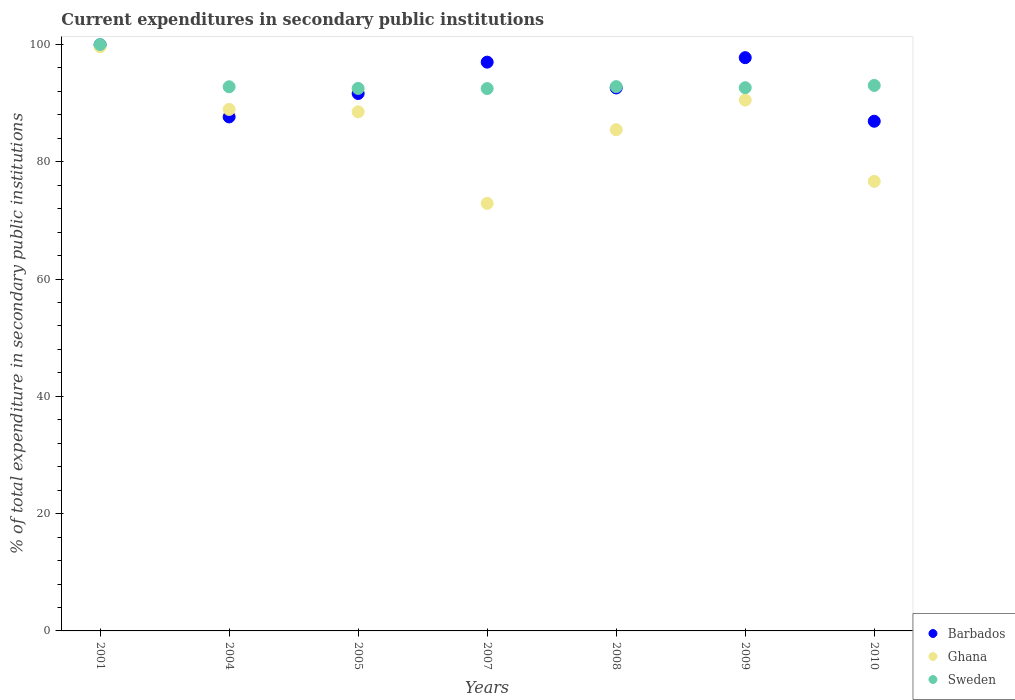How many different coloured dotlines are there?
Offer a very short reply. 3. What is the current expenditures in secondary public institutions in Sweden in 2010?
Give a very brief answer. 93.02. Across all years, what is the maximum current expenditures in secondary public institutions in Ghana?
Offer a very short reply. 99.62. Across all years, what is the minimum current expenditures in secondary public institutions in Ghana?
Provide a succinct answer. 72.91. In which year was the current expenditures in secondary public institutions in Sweden maximum?
Ensure brevity in your answer.  2001. In which year was the current expenditures in secondary public institutions in Barbados minimum?
Ensure brevity in your answer.  2010. What is the total current expenditures in secondary public institutions in Sweden in the graph?
Give a very brief answer. 656.27. What is the difference between the current expenditures in secondary public institutions in Ghana in 2001 and that in 2010?
Your answer should be compact. 22.95. What is the difference between the current expenditures in secondary public institutions in Sweden in 2005 and the current expenditures in secondary public institutions in Barbados in 2008?
Provide a short and direct response. -0.08. What is the average current expenditures in secondary public institutions in Sweden per year?
Your answer should be compact. 93.75. In the year 2001, what is the difference between the current expenditures in secondary public institutions in Barbados and current expenditures in secondary public institutions in Sweden?
Offer a very short reply. -0.06. What is the ratio of the current expenditures in secondary public institutions in Sweden in 2001 to that in 2004?
Your answer should be very brief. 1.08. Is the current expenditures in secondary public institutions in Barbados in 2005 less than that in 2010?
Provide a succinct answer. No. What is the difference between the highest and the second highest current expenditures in secondary public institutions in Sweden?
Your response must be concise. 6.98. What is the difference between the highest and the lowest current expenditures in secondary public institutions in Ghana?
Offer a terse response. 26.71. Is the sum of the current expenditures in secondary public institutions in Ghana in 2001 and 2004 greater than the maximum current expenditures in secondary public institutions in Sweden across all years?
Offer a very short reply. Yes. Is it the case that in every year, the sum of the current expenditures in secondary public institutions in Ghana and current expenditures in secondary public institutions in Sweden  is greater than the current expenditures in secondary public institutions in Barbados?
Offer a terse response. Yes. Is the current expenditures in secondary public institutions in Barbados strictly greater than the current expenditures in secondary public institutions in Sweden over the years?
Give a very brief answer. No. How many dotlines are there?
Your response must be concise. 3. How many years are there in the graph?
Offer a very short reply. 7. Does the graph contain any zero values?
Your response must be concise. No. Where does the legend appear in the graph?
Provide a short and direct response. Bottom right. How are the legend labels stacked?
Ensure brevity in your answer.  Vertical. What is the title of the graph?
Your answer should be compact. Current expenditures in secondary public institutions. Does "Libya" appear as one of the legend labels in the graph?
Your answer should be compact. No. What is the label or title of the X-axis?
Make the answer very short. Years. What is the label or title of the Y-axis?
Your answer should be compact. % of total expenditure in secondary public institutions. What is the % of total expenditure in secondary public institutions in Barbados in 2001?
Your response must be concise. 99.94. What is the % of total expenditure in secondary public institutions of Ghana in 2001?
Provide a succinct answer. 99.62. What is the % of total expenditure in secondary public institutions in Sweden in 2001?
Make the answer very short. 100. What is the % of total expenditure in secondary public institutions of Barbados in 2004?
Your answer should be very brief. 87.65. What is the % of total expenditure in secondary public institutions of Ghana in 2004?
Offer a terse response. 88.93. What is the % of total expenditure in secondary public institutions in Sweden in 2004?
Your answer should be compact. 92.79. What is the % of total expenditure in secondary public institutions of Barbados in 2005?
Ensure brevity in your answer.  91.65. What is the % of total expenditure in secondary public institutions of Ghana in 2005?
Offer a very short reply. 88.52. What is the % of total expenditure in secondary public institutions in Sweden in 2005?
Your answer should be very brief. 92.51. What is the % of total expenditure in secondary public institutions in Barbados in 2007?
Give a very brief answer. 96.99. What is the % of total expenditure in secondary public institutions of Ghana in 2007?
Provide a short and direct response. 72.91. What is the % of total expenditure in secondary public institutions in Sweden in 2007?
Keep it short and to the point. 92.49. What is the % of total expenditure in secondary public institutions in Barbados in 2008?
Provide a succinct answer. 92.59. What is the % of total expenditure in secondary public institutions of Ghana in 2008?
Provide a succinct answer. 85.48. What is the % of total expenditure in secondary public institutions of Sweden in 2008?
Give a very brief answer. 92.82. What is the % of total expenditure in secondary public institutions in Barbados in 2009?
Offer a terse response. 97.76. What is the % of total expenditure in secondary public institutions in Ghana in 2009?
Provide a succinct answer. 90.52. What is the % of total expenditure in secondary public institutions in Sweden in 2009?
Ensure brevity in your answer.  92.63. What is the % of total expenditure in secondary public institutions of Barbados in 2010?
Keep it short and to the point. 86.92. What is the % of total expenditure in secondary public institutions in Ghana in 2010?
Make the answer very short. 76.67. What is the % of total expenditure in secondary public institutions in Sweden in 2010?
Your answer should be compact. 93.02. Across all years, what is the maximum % of total expenditure in secondary public institutions of Barbados?
Ensure brevity in your answer.  99.94. Across all years, what is the maximum % of total expenditure in secondary public institutions in Ghana?
Keep it short and to the point. 99.62. Across all years, what is the minimum % of total expenditure in secondary public institutions in Barbados?
Offer a very short reply. 86.92. Across all years, what is the minimum % of total expenditure in secondary public institutions of Ghana?
Offer a terse response. 72.91. Across all years, what is the minimum % of total expenditure in secondary public institutions of Sweden?
Keep it short and to the point. 92.49. What is the total % of total expenditure in secondary public institutions of Barbados in the graph?
Your response must be concise. 653.51. What is the total % of total expenditure in secondary public institutions of Ghana in the graph?
Your answer should be compact. 602.64. What is the total % of total expenditure in secondary public institutions of Sweden in the graph?
Provide a short and direct response. 656.27. What is the difference between the % of total expenditure in secondary public institutions of Barbados in 2001 and that in 2004?
Offer a very short reply. 12.29. What is the difference between the % of total expenditure in secondary public institutions in Ghana in 2001 and that in 2004?
Your answer should be very brief. 10.69. What is the difference between the % of total expenditure in secondary public institutions in Sweden in 2001 and that in 2004?
Your response must be concise. 7.21. What is the difference between the % of total expenditure in secondary public institutions in Barbados in 2001 and that in 2005?
Make the answer very short. 8.29. What is the difference between the % of total expenditure in secondary public institutions of Ghana in 2001 and that in 2005?
Your answer should be compact. 11.09. What is the difference between the % of total expenditure in secondary public institutions of Sweden in 2001 and that in 2005?
Provide a succinct answer. 7.49. What is the difference between the % of total expenditure in secondary public institutions in Barbados in 2001 and that in 2007?
Give a very brief answer. 2.95. What is the difference between the % of total expenditure in secondary public institutions in Ghana in 2001 and that in 2007?
Ensure brevity in your answer.  26.71. What is the difference between the % of total expenditure in secondary public institutions in Sweden in 2001 and that in 2007?
Provide a short and direct response. 7.51. What is the difference between the % of total expenditure in secondary public institutions in Barbados in 2001 and that in 2008?
Ensure brevity in your answer.  7.35. What is the difference between the % of total expenditure in secondary public institutions of Ghana in 2001 and that in 2008?
Make the answer very short. 14.14. What is the difference between the % of total expenditure in secondary public institutions in Sweden in 2001 and that in 2008?
Keep it short and to the point. 7.18. What is the difference between the % of total expenditure in secondary public institutions of Barbados in 2001 and that in 2009?
Make the answer very short. 2.18. What is the difference between the % of total expenditure in secondary public institutions in Ghana in 2001 and that in 2009?
Ensure brevity in your answer.  9.1. What is the difference between the % of total expenditure in secondary public institutions in Sweden in 2001 and that in 2009?
Give a very brief answer. 7.37. What is the difference between the % of total expenditure in secondary public institutions in Barbados in 2001 and that in 2010?
Provide a short and direct response. 13.03. What is the difference between the % of total expenditure in secondary public institutions in Ghana in 2001 and that in 2010?
Offer a very short reply. 22.95. What is the difference between the % of total expenditure in secondary public institutions of Sweden in 2001 and that in 2010?
Offer a very short reply. 6.98. What is the difference between the % of total expenditure in secondary public institutions of Barbados in 2004 and that in 2005?
Make the answer very short. -3.99. What is the difference between the % of total expenditure in secondary public institutions of Ghana in 2004 and that in 2005?
Make the answer very short. 0.4. What is the difference between the % of total expenditure in secondary public institutions in Sweden in 2004 and that in 2005?
Your answer should be compact. 0.28. What is the difference between the % of total expenditure in secondary public institutions of Barbados in 2004 and that in 2007?
Your response must be concise. -9.34. What is the difference between the % of total expenditure in secondary public institutions of Ghana in 2004 and that in 2007?
Provide a succinct answer. 16.02. What is the difference between the % of total expenditure in secondary public institutions of Sweden in 2004 and that in 2007?
Offer a very short reply. 0.3. What is the difference between the % of total expenditure in secondary public institutions of Barbados in 2004 and that in 2008?
Give a very brief answer. -4.94. What is the difference between the % of total expenditure in secondary public institutions of Ghana in 2004 and that in 2008?
Your answer should be compact. 3.45. What is the difference between the % of total expenditure in secondary public institutions of Sweden in 2004 and that in 2008?
Provide a succinct answer. -0.03. What is the difference between the % of total expenditure in secondary public institutions of Barbados in 2004 and that in 2009?
Your response must be concise. -10.1. What is the difference between the % of total expenditure in secondary public institutions of Ghana in 2004 and that in 2009?
Your answer should be very brief. -1.59. What is the difference between the % of total expenditure in secondary public institutions of Sweden in 2004 and that in 2009?
Make the answer very short. 0.16. What is the difference between the % of total expenditure in secondary public institutions in Barbados in 2004 and that in 2010?
Give a very brief answer. 0.74. What is the difference between the % of total expenditure in secondary public institutions in Ghana in 2004 and that in 2010?
Provide a succinct answer. 12.26. What is the difference between the % of total expenditure in secondary public institutions of Sweden in 2004 and that in 2010?
Offer a terse response. -0.23. What is the difference between the % of total expenditure in secondary public institutions in Barbados in 2005 and that in 2007?
Provide a short and direct response. -5.35. What is the difference between the % of total expenditure in secondary public institutions of Ghana in 2005 and that in 2007?
Offer a terse response. 15.61. What is the difference between the % of total expenditure in secondary public institutions in Sweden in 2005 and that in 2007?
Your answer should be very brief. 0.02. What is the difference between the % of total expenditure in secondary public institutions in Barbados in 2005 and that in 2008?
Provide a succinct answer. -0.95. What is the difference between the % of total expenditure in secondary public institutions in Ghana in 2005 and that in 2008?
Provide a short and direct response. 3.05. What is the difference between the % of total expenditure in secondary public institutions in Sweden in 2005 and that in 2008?
Give a very brief answer. -0.31. What is the difference between the % of total expenditure in secondary public institutions in Barbados in 2005 and that in 2009?
Give a very brief answer. -6.11. What is the difference between the % of total expenditure in secondary public institutions of Ghana in 2005 and that in 2009?
Offer a very short reply. -2. What is the difference between the % of total expenditure in secondary public institutions of Sweden in 2005 and that in 2009?
Your answer should be compact. -0.12. What is the difference between the % of total expenditure in secondary public institutions of Barbados in 2005 and that in 2010?
Give a very brief answer. 4.73. What is the difference between the % of total expenditure in secondary public institutions in Ghana in 2005 and that in 2010?
Give a very brief answer. 11.86. What is the difference between the % of total expenditure in secondary public institutions of Sweden in 2005 and that in 2010?
Ensure brevity in your answer.  -0.51. What is the difference between the % of total expenditure in secondary public institutions of Barbados in 2007 and that in 2008?
Ensure brevity in your answer.  4.4. What is the difference between the % of total expenditure in secondary public institutions of Ghana in 2007 and that in 2008?
Offer a terse response. -12.57. What is the difference between the % of total expenditure in secondary public institutions of Sweden in 2007 and that in 2008?
Offer a very short reply. -0.33. What is the difference between the % of total expenditure in secondary public institutions in Barbados in 2007 and that in 2009?
Give a very brief answer. -0.76. What is the difference between the % of total expenditure in secondary public institutions of Ghana in 2007 and that in 2009?
Provide a succinct answer. -17.61. What is the difference between the % of total expenditure in secondary public institutions in Sweden in 2007 and that in 2009?
Keep it short and to the point. -0.15. What is the difference between the % of total expenditure in secondary public institutions in Barbados in 2007 and that in 2010?
Ensure brevity in your answer.  10.08. What is the difference between the % of total expenditure in secondary public institutions of Ghana in 2007 and that in 2010?
Your answer should be compact. -3.76. What is the difference between the % of total expenditure in secondary public institutions in Sweden in 2007 and that in 2010?
Give a very brief answer. -0.54. What is the difference between the % of total expenditure in secondary public institutions of Barbados in 2008 and that in 2009?
Provide a short and direct response. -5.16. What is the difference between the % of total expenditure in secondary public institutions in Ghana in 2008 and that in 2009?
Give a very brief answer. -5.04. What is the difference between the % of total expenditure in secondary public institutions of Sweden in 2008 and that in 2009?
Give a very brief answer. 0.19. What is the difference between the % of total expenditure in secondary public institutions in Barbados in 2008 and that in 2010?
Your answer should be compact. 5.68. What is the difference between the % of total expenditure in secondary public institutions of Ghana in 2008 and that in 2010?
Give a very brief answer. 8.81. What is the difference between the % of total expenditure in secondary public institutions in Sweden in 2008 and that in 2010?
Offer a terse response. -0.2. What is the difference between the % of total expenditure in secondary public institutions of Barbados in 2009 and that in 2010?
Your answer should be very brief. 10.84. What is the difference between the % of total expenditure in secondary public institutions of Ghana in 2009 and that in 2010?
Provide a succinct answer. 13.85. What is the difference between the % of total expenditure in secondary public institutions of Sweden in 2009 and that in 2010?
Your answer should be very brief. -0.39. What is the difference between the % of total expenditure in secondary public institutions in Barbados in 2001 and the % of total expenditure in secondary public institutions in Ghana in 2004?
Your response must be concise. 11.01. What is the difference between the % of total expenditure in secondary public institutions of Barbados in 2001 and the % of total expenditure in secondary public institutions of Sweden in 2004?
Give a very brief answer. 7.15. What is the difference between the % of total expenditure in secondary public institutions in Ghana in 2001 and the % of total expenditure in secondary public institutions in Sweden in 2004?
Give a very brief answer. 6.82. What is the difference between the % of total expenditure in secondary public institutions of Barbados in 2001 and the % of total expenditure in secondary public institutions of Ghana in 2005?
Give a very brief answer. 11.42. What is the difference between the % of total expenditure in secondary public institutions in Barbados in 2001 and the % of total expenditure in secondary public institutions in Sweden in 2005?
Provide a short and direct response. 7.43. What is the difference between the % of total expenditure in secondary public institutions in Ghana in 2001 and the % of total expenditure in secondary public institutions in Sweden in 2005?
Your answer should be very brief. 7.11. What is the difference between the % of total expenditure in secondary public institutions in Barbados in 2001 and the % of total expenditure in secondary public institutions in Ghana in 2007?
Offer a very short reply. 27.03. What is the difference between the % of total expenditure in secondary public institutions in Barbados in 2001 and the % of total expenditure in secondary public institutions in Sweden in 2007?
Your answer should be compact. 7.45. What is the difference between the % of total expenditure in secondary public institutions in Ghana in 2001 and the % of total expenditure in secondary public institutions in Sweden in 2007?
Your answer should be compact. 7.13. What is the difference between the % of total expenditure in secondary public institutions of Barbados in 2001 and the % of total expenditure in secondary public institutions of Ghana in 2008?
Your response must be concise. 14.46. What is the difference between the % of total expenditure in secondary public institutions of Barbados in 2001 and the % of total expenditure in secondary public institutions of Sweden in 2008?
Offer a very short reply. 7.12. What is the difference between the % of total expenditure in secondary public institutions in Ghana in 2001 and the % of total expenditure in secondary public institutions in Sweden in 2008?
Ensure brevity in your answer.  6.8. What is the difference between the % of total expenditure in secondary public institutions of Barbados in 2001 and the % of total expenditure in secondary public institutions of Ghana in 2009?
Provide a short and direct response. 9.42. What is the difference between the % of total expenditure in secondary public institutions in Barbados in 2001 and the % of total expenditure in secondary public institutions in Sweden in 2009?
Your answer should be very brief. 7.31. What is the difference between the % of total expenditure in secondary public institutions in Ghana in 2001 and the % of total expenditure in secondary public institutions in Sweden in 2009?
Your response must be concise. 6.98. What is the difference between the % of total expenditure in secondary public institutions of Barbados in 2001 and the % of total expenditure in secondary public institutions of Ghana in 2010?
Make the answer very short. 23.27. What is the difference between the % of total expenditure in secondary public institutions in Barbados in 2001 and the % of total expenditure in secondary public institutions in Sweden in 2010?
Offer a very short reply. 6.92. What is the difference between the % of total expenditure in secondary public institutions of Ghana in 2001 and the % of total expenditure in secondary public institutions of Sweden in 2010?
Offer a very short reply. 6.59. What is the difference between the % of total expenditure in secondary public institutions in Barbados in 2004 and the % of total expenditure in secondary public institutions in Ghana in 2005?
Provide a short and direct response. -0.87. What is the difference between the % of total expenditure in secondary public institutions of Barbados in 2004 and the % of total expenditure in secondary public institutions of Sweden in 2005?
Provide a succinct answer. -4.86. What is the difference between the % of total expenditure in secondary public institutions in Ghana in 2004 and the % of total expenditure in secondary public institutions in Sweden in 2005?
Your answer should be very brief. -3.58. What is the difference between the % of total expenditure in secondary public institutions of Barbados in 2004 and the % of total expenditure in secondary public institutions of Ghana in 2007?
Keep it short and to the point. 14.75. What is the difference between the % of total expenditure in secondary public institutions in Barbados in 2004 and the % of total expenditure in secondary public institutions in Sweden in 2007?
Your answer should be very brief. -4.83. What is the difference between the % of total expenditure in secondary public institutions in Ghana in 2004 and the % of total expenditure in secondary public institutions in Sweden in 2007?
Keep it short and to the point. -3.56. What is the difference between the % of total expenditure in secondary public institutions of Barbados in 2004 and the % of total expenditure in secondary public institutions of Ghana in 2008?
Offer a terse response. 2.18. What is the difference between the % of total expenditure in secondary public institutions of Barbados in 2004 and the % of total expenditure in secondary public institutions of Sweden in 2008?
Keep it short and to the point. -5.16. What is the difference between the % of total expenditure in secondary public institutions of Ghana in 2004 and the % of total expenditure in secondary public institutions of Sweden in 2008?
Provide a succinct answer. -3.89. What is the difference between the % of total expenditure in secondary public institutions in Barbados in 2004 and the % of total expenditure in secondary public institutions in Ghana in 2009?
Provide a short and direct response. -2.86. What is the difference between the % of total expenditure in secondary public institutions in Barbados in 2004 and the % of total expenditure in secondary public institutions in Sweden in 2009?
Give a very brief answer. -4.98. What is the difference between the % of total expenditure in secondary public institutions of Ghana in 2004 and the % of total expenditure in secondary public institutions of Sweden in 2009?
Give a very brief answer. -3.71. What is the difference between the % of total expenditure in secondary public institutions in Barbados in 2004 and the % of total expenditure in secondary public institutions in Ghana in 2010?
Offer a terse response. 10.99. What is the difference between the % of total expenditure in secondary public institutions in Barbados in 2004 and the % of total expenditure in secondary public institutions in Sweden in 2010?
Your answer should be very brief. -5.37. What is the difference between the % of total expenditure in secondary public institutions in Ghana in 2004 and the % of total expenditure in secondary public institutions in Sweden in 2010?
Your answer should be compact. -4.1. What is the difference between the % of total expenditure in secondary public institutions of Barbados in 2005 and the % of total expenditure in secondary public institutions of Ghana in 2007?
Your response must be concise. 18.74. What is the difference between the % of total expenditure in secondary public institutions of Barbados in 2005 and the % of total expenditure in secondary public institutions of Sweden in 2007?
Keep it short and to the point. -0.84. What is the difference between the % of total expenditure in secondary public institutions of Ghana in 2005 and the % of total expenditure in secondary public institutions of Sweden in 2007?
Keep it short and to the point. -3.97. What is the difference between the % of total expenditure in secondary public institutions in Barbados in 2005 and the % of total expenditure in secondary public institutions in Ghana in 2008?
Make the answer very short. 6.17. What is the difference between the % of total expenditure in secondary public institutions of Barbados in 2005 and the % of total expenditure in secondary public institutions of Sweden in 2008?
Offer a very short reply. -1.17. What is the difference between the % of total expenditure in secondary public institutions of Ghana in 2005 and the % of total expenditure in secondary public institutions of Sweden in 2008?
Your answer should be compact. -4.3. What is the difference between the % of total expenditure in secondary public institutions of Barbados in 2005 and the % of total expenditure in secondary public institutions of Ghana in 2009?
Ensure brevity in your answer.  1.13. What is the difference between the % of total expenditure in secondary public institutions of Barbados in 2005 and the % of total expenditure in secondary public institutions of Sweden in 2009?
Provide a short and direct response. -0.99. What is the difference between the % of total expenditure in secondary public institutions of Ghana in 2005 and the % of total expenditure in secondary public institutions of Sweden in 2009?
Your answer should be compact. -4.11. What is the difference between the % of total expenditure in secondary public institutions of Barbados in 2005 and the % of total expenditure in secondary public institutions of Ghana in 2010?
Provide a succinct answer. 14.98. What is the difference between the % of total expenditure in secondary public institutions of Barbados in 2005 and the % of total expenditure in secondary public institutions of Sweden in 2010?
Give a very brief answer. -1.38. What is the difference between the % of total expenditure in secondary public institutions of Ghana in 2005 and the % of total expenditure in secondary public institutions of Sweden in 2010?
Your answer should be very brief. -4.5. What is the difference between the % of total expenditure in secondary public institutions in Barbados in 2007 and the % of total expenditure in secondary public institutions in Ghana in 2008?
Offer a very short reply. 11.52. What is the difference between the % of total expenditure in secondary public institutions in Barbados in 2007 and the % of total expenditure in secondary public institutions in Sweden in 2008?
Ensure brevity in your answer.  4.17. What is the difference between the % of total expenditure in secondary public institutions of Ghana in 2007 and the % of total expenditure in secondary public institutions of Sweden in 2008?
Offer a terse response. -19.91. What is the difference between the % of total expenditure in secondary public institutions in Barbados in 2007 and the % of total expenditure in secondary public institutions in Ghana in 2009?
Make the answer very short. 6.48. What is the difference between the % of total expenditure in secondary public institutions in Barbados in 2007 and the % of total expenditure in secondary public institutions in Sweden in 2009?
Keep it short and to the point. 4.36. What is the difference between the % of total expenditure in secondary public institutions of Ghana in 2007 and the % of total expenditure in secondary public institutions of Sweden in 2009?
Ensure brevity in your answer.  -19.72. What is the difference between the % of total expenditure in secondary public institutions in Barbados in 2007 and the % of total expenditure in secondary public institutions in Ghana in 2010?
Ensure brevity in your answer.  20.33. What is the difference between the % of total expenditure in secondary public institutions in Barbados in 2007 and the % of total expenditure in secondary public institutions in Sweden in 2010?
Your answer should be very brief. 3.97. What is the difference between the % of total expenditure in secondary public institutions in Ghana in 2007 and the % of total expenditure in secondary public institutions in Sweden in 2010?
Ensure brevity in your answer.  -20.11. What is the difference between the % of total expenditure in secondary public institutions of Barbados in 2008 and the % of total expenditure in secondary public institutions of Ghana in 2009?
Your answer should be compact. 2.07. What is the difference between the % of total expenditure in secondary public institutions of Barbados in 2008 and the % of total expenditure in secondary public institutions of Sweden in 2009?
Your answer should be very brief. -0.04. What is the difference between the % of total expenditure in secondary public institutions of Ghana in 2008 and the % of total expenditure in secondary public institutions of Sweden in 2009?
Make the answer very short. -7.16. What is the difference between the % of total expenditure in secondary public institutions of Barbados in 2008 and the % of total expenditure in secondary public institutions of Ghana in 2010?
Offer a terse response. 15.93. What is the difference between the % of total expenditure in secondary public institutions in Barbados in 2008 and the % of total expenditure in secondary public institutions in Sweden in 2010?
Provide a short and direct response. -0.43. What is the difference between the % of total expenditure in secondary public institutions of Ghana in 2008 and the % of total expenditure in secondary public institutions of Sweden in 2010?
Give a very brief answer. -7.55. What is the difference between the % of total expenditure in secondary public institutions of Barbados in 2009 and the % of total expenditure in secondary public institutions of Ghana in 2010?
Your answer should be compact. 21.09. What is the difference between the % of total expenditure in secondary public institutions in Barbados in 2009 and the % of total expenditure in secondary public institutions in Sweden in 2010?
Make the answer very short. 4.73. What is the difference between the % of total expenditure in secondary public institutions in Ghana in 2009 and the % of total expenditure in secondary public institutions in Sweden in 2010?
Offer a very short reply. -2.51. What is the average % of total expenditure in secondary public institutions in Barbados per year?
Your response must be concise. 93.36. What is the average % of total expenditure in secondary public institutions of Ghana per year?
Your response must be concise. 86.09. What is the average % of total expenditure in secondary public institutions of Sweden per year?
Your answer should be compact. 93.75. In the year 2001, what is the difference between the % of total expenditure in secondary public institutions in Barbados and % of total expenditure in secondary public institutions in Ghana?
Keep it short and to the point. 0.32. In the year 2001, what is the difference between the % of total expenditure in secondary public institutions of Barbados and % of total expenditure in secondary public institutions of Sweden?
Ensure brevity in your answer.  -0.06. In the year 2001, what is the difference between the % of total expenditure in secondary public institutions in Ghana and % of total expenditure in secondary public institutions in Sweden?
Your answer should be compact. -0.38. In the year 2004, what is the difference between the % of total expenditure in secondary public institutions of Barbados and % of total expenditure in secondary public institutions of Ghana?
Offer a terse response. -1.27. In the year 2004, what is the difference between the % of total expenditure in secondary public institutions of Barbados and % of total expenditure in secondary public institutions of Sweden?
Provide a succinct answer. -5.14. In the year 2004, what is the difference between the % of total expenditure in secondary public institutions in Ghana and % of total expenditure in secondary public institutions in Sweden?
Provide a short and direct response. -3.87. In the year 2005, what is the difference between the % of total expenditure in secondary public institutions of Barbados and % of total expenditure in secondary public institutions of Ghana?
Make the answer very short. 3.12. In the year 2005, what is the difference between the % of total expenditure in secondary public institutions in Barbados and % of total expenditure in secondary public institutions in Sweden?
Provide a succinct answer. -0.86. In the year 2005, what is the difference between the % of total expenditure in secondary public institutions in Ghana and % of total expenditure in secondary public institutions in Sweden?
Provide a short and direct response. -3.99. In the year 2007, what is the difference between the % of total expenditure in secondary public institutions of Barbados and % of total expenditure in secondary public institutions of Ghana?
Ensure brevity in your answer.  24.08. In the year 2007, what is the difference between the % of total expenditure in secondary public institutions in Barbados and % of total expenditure in secondary public institutions in Sweden?
Keep it short and to the point. 4.5. In the year 2007, what is the difference between the % of total expenditure in secondary public institutions of Ghana and % of total expenditure in secondary public institutions of Sweden?
Offer a terse response. -19.58. In the year 2008, what is the difference between the % of total expenditure in secondary public institutions in Barbados and % of total expenditure in secondary public institutions in Ghana?
Your answer should be very brief. 7.12. In the year 2008, what is the difference between the % of total expenditure in secondary public institutions in Barbados and % of total expenditure in secondary public institutions in Sweden?
Make the answer very short. -0.23. In the year 2008, what is the difference between the % of total expenditure in secondary public institutions of Ghana and % of total expenditure in secondary public institutions of Sweden?
Give a very brief answer. -7.34. In the year 2009, what is the difference between the % of total expenditure in secondary public institutions of Barbados and % of total expenditure in secondary public institutions of Ghana?
Make the answer very short. 7.24. In the year 2009, what is the difference between the % of total expenditure in secondary public institutions in Barbados and % of total expenditure in secondary public institutions in Sweden?
Offer a terse response. 5.12. In the year 2009, what is the difference between the % of total expenditure in secondary public institutions of Ghana and % of total expenditure in secondary public institutions of Sweden?
Make the answer very short. -2.12. In the year 2010, what is the difference between the % of total expenditure in secondary public institutions of Barbados and % of total expenditure in secondary public institutions of Ghana?
Your answer should be very brief. 10.25. In the year 2010, what is the difference between the % of total expenditure in secondary public institutions of Barbados and % of total expenditure in secondary public institutions of Sweden?
Give a very brief answer. -6.11. In the year 2010, what is the difference between the % of total expenditure in secondary public institutions of Ghana and % of total expenditure in secondary public institutions of Sweden?
Keep it short and to the point. -16.36. What is the ratio of the % of total expenditure in secondary public institutions in Barbados in 2001 to that in 2004?
Give a very brief answer. 1.14. What is the ratio of the % of total expenditure in secondary public institutions of Ghana in 2001 to that in 2004?
Ensure brevity in your answer.  1.12. What is the ratio of the % of total expenditure in secondary public institutions of Sweden in 2001 to that in 2004?
Give a very brief answer. 1.08. What is the ratio of the % of total expenditure in secondary public institutions of Barbados in 2001 to that in 2005?
Give a very brief answer. 1.09. What is the ratio of the % of total expenditure in secondary public institutions of Ghana in 2001 to that in 2005?
Provide a succinct answer. 1.13. What is the ratio of the % of total expenditure in secondary public institutions in Sweden in 2001 to that in 2005?
Give a very brief answer. 1.08. What is the ratio of the % of total expenditure in secondary public institutions of Barbados in 2001 to that in 2007?
Keep it short and to the point. 1.03. What is the ratio of the % of total expenditure in secondary public institutions in Ghana in 2001 to that in 2007?
Provide a succinct answer. 1.37. What is the ratio of the % of total expenditure in secondary public institutions of Sweden in 2001 to that in 2007?
Ensure brevity in your answer.  1.08. What is the ratio of the % of total expenditure in secondary public institutions of Barbados in 2001 to that in 2008?
Ensure brevity in your answer.  1.08. What is the ratio of the % of total expenditure in secondary public institutions in Ghana in 2001 to that in 2008?
Ensure brevity in your answer.  1.17. What is the ratio of the % of total expenditure in secondary public institutions of Sweden in 2001 to that in 2008?
Offer a terse response. 1.08. What is the ratio of the % of total expenditure in secondary public institutions of Barbados in 2001 to that in 2009?
Provide a short and direct response. 1.02. What is the ratio of the % of total expenditure in secondary public institutions of Ghana in 2001 to that in 2009?
Your answer should be very brief. 1.1. What is the ratio of the % of total expenditure in secondary public institutions in Sweden in 2001 to that in 2009?
Give a very brief answer. 1.08. What is the ratio of the % of total expenditure in secondary public institutions in Barbados in 2001 to that in 2010?
Provide a short and direct response. 1.15. What is the ratio of the % of total expenditure in secondary public institutions in Ghana in 2001 to that in 2010?
Give a very brief answer. 1.3. What is the ratio of the % of total expenditure in secondary public institutions in Sweden in 2001 to that in 2010?
Provide a succinct answer. 1.07. What is the ratio of the % of total expenditure in secondary public institutions of Barbados in 2004 to that in 2005?
Keep it short and to the point. 0.96. What is the ratio of the % of total expenditure in secondary public institutions of Ghana in 2004 to that in 2005?
Your answer should be very brief. 1. What is the ratio of the % of total expenditure in secondary public institutions in Sweden in 2004 to that in 2005?
Provide a short and direct response. 1. What is the ratio of the % of total expenditure in secondary public institutions of Barbados in 2004 to that in 2007?
Your response must be concise. 0.9. What is the ratio of the % of total expenditure in secondary public institutions of Ghana in 2004 to that in 2007?
Ensure brevity in your answer.  1.22. What is the ratio of the % of total expenditure in secondary public institutions in Sweden in 2004 to that in 2007?
Make the answer very short. 1. What is the ratio of the % of total expenditure in secondary public institutions in Barbados in 2004 to that in 2008?
Keep it short and to the point. 0.95. What is the ratio of the % of total expenditure in secondary public institutions in Ghana in 2004 to that in 2008?
Keep it short and to the point. 1.04. What is the ratio of the % of total expenditure in secondary public institutions of Sweden in 2004 to that in 2008?
Provide a succinct answer. 1. What is the ratio of the % of total expenditure in secondary public institutions in Barbados in 2004 to that in 2009?
Your response must be concise. 0.9. What is the ratio of the % of total expenditure in secondary public institutions in Ghana in 2004 to that in 2009?
Make the answer very short. 0.98. What is the ratio of the % of total expenditure in secondary public institutions of Sweden in 2004 to that in 2009?
Give a very brief answer. 1. What is the ratio of the % of total expenditure in secondary public institutions of Barbados in 2004 to that in 2010?
Give a very brief answer. 1.01. What is the ratio of the % of total expenditure in secondary public institutions of Ghana in 2004 to that in 2010?
Provide a short and direct response. 1.16. What is the ratio of the % of total expenditure in secondary public institutions in Barbados in 2005 to that in 2007?
Provide a succinct answer. 0.94. What is the ratio of the % of total expenditure in secondary public institutions of Ghana in 2005 to that in 2007?
Offer a very short reply. 1.21. What is the ratio of the % of total expenditure in secondary public institutions of Ghana in 2005 to that in 2008?
Ensure brevity in your answer.  1.04. What is the ratio of the % of total expenditure in secondary public institutions of Sweden in 2005 to that in 2008?
Your answer should be very brief. 1. What is the ratio of the % of total expenditure in secondary public institutions in Ghana in 2005 to that in 2009?
Give a very brief answer. 0.98. What is the ratio of the % of total expenditure in secondary public institutions of Sweden in 2005 to that in 2009?
Give a very brief answer. 1. What is the ratio of the % of total expenditure in secondary public institutions of Barbados in 2005 to that in 2010?
Make the answer very short. 1.05. What is the ratio of the % of total expenditure in secondary public institutions in Ghana in 2005 to that in 2010?
Make the answer very short. 1.15. What is the ratio of the % of total expenditure in secondary public institutions of Sweden in 2005 to that in 2010?
Your answer should be very brief. 0.99. What is the ratio of the % of total expenditure in secondary public institutions in Barbados in 2007 to that in 2008?
Provide a short and direct response. 1.05. What is the ratio of the % of total expenditure in secondary public institutions in Ghana in 2007 to that in 2008?
Offer a terse response. 0.85. What is the ratio of the % of total expenditure in secondary public institutions in Sweden in 2007 to that in 2008?
Keep it short and to the point. 1. What is the ratio of the % of total expenditure in secondary public institutions in Barbados in 2007 to that in 2009?
Provide a short and direct response. 0.99. What is the ratio of the % of total expenditure in secondary public institutions of Ghana in 2007 to that in 2009?
Offer a very short reply. 0.81. What is the ratio of the % of total expenditure in secondary public institutions of Sweden in 2007 to that in 2009?
Keep it short and to the point. 1. What is the ratio of the % of total expenditure in secondary public institutions of Barbados in 2007 to that in 2010?
Provide a succinct answer. 1.12. What is the ratio of the % of total expenditure in secondary public institutions in Ghana in 2007 to that in 2010?
Keep it short and to the point. 0.95. What is the ratio of the % of total expenditure in secondary public institutions of Barbados in 2008 to that in 2009?
Your response must be concise. 0.95. What is the ratio of the % of total expenditure in secondary public institutions in Ghana in 2008 to that in 2009?
Your response must be concise. 0.94. What is the ratio of the % of total expenditure in secondary public institutions in Barbados in 2008 to that in 2010?
Give a very brief answer. 1.07. What is the ratio of the % of total expenditure in secondary public institutions of Ghana in 2008 to that in 2010?
Your answer should be very brief. 1.11. What is the ratio of the % of total expenditure in secondary public institutions of Barbados in 2009 to that in 2010?
Your answer should be very brief. 1.12. What is the ratio of the % of total expenditure in secondary public institutions of Ghana in 2009 to that in 2010?
Your response must be concise. 1.18. What is the difference between the highest and the second highest % of total expenditure in secondary public institutions in Barbados?
Your answer should be compact. 2.18. What is the difference between the highest and the second highest % of total expenditure in secondary public institutions in Ghana?
Your response must be concise. 9.1. What is the difference between the highest and the second highest % of total expenditure in secondary public institutions of Sweden?
Keep it short and to the point. 6.98. What is the difference between the highest and the lowest % of total expenditure in secondary public institutions in Barbados?
Keep it short and to the point. 13.03. What is the difference between the highest and the lowest % of total expenditure in secondary public institutions in Ghana?
Give a very brief answer. 26.71. What is the difference between the highest and the lowest % of total expenditure in secondary public institutions in Sweden?
Your response must be concise. 7.51. 